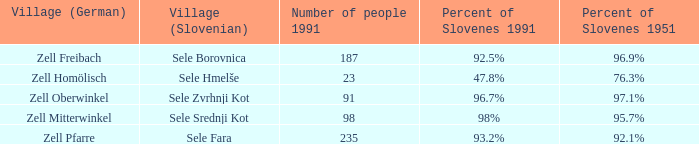Provide me with the name of all the village (German) that are part of the village (Slovenian) with sele borovnica. Zell Freibach. 